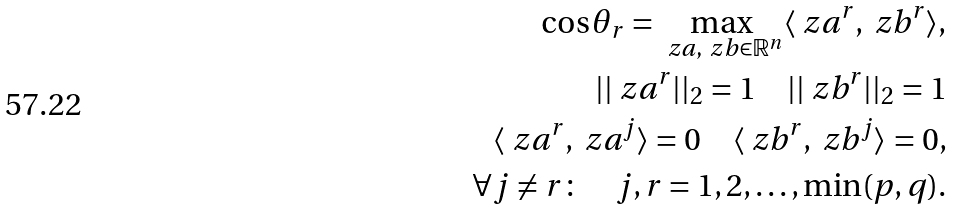Convert formula to latex. <formula><loc_0><loc_0><loc_500><loc_500>\cos \theta _ { r } = \max _ { \ z a , \ z b \in \mathbb { R } ^ { n } } \langle \ z a ^ { r } , \ z b ^ { r } \rangle , \\ | | \ z a ^ { r } | | _ { 2 } = 1 \quad | | \ z b ^ { r } | | _ { 2 } = 1 \\ \langle \ z a ^ { r } , \ z a ^ { j } \rangle = 0 \quad \langle \ z b ^ { r } , \ z b ^ { j } \rangle = 0 , \\ \forall j \neq r \colon \quad j , r = 1 , 2 , \dots , \min ( p , q ) .</formula> 